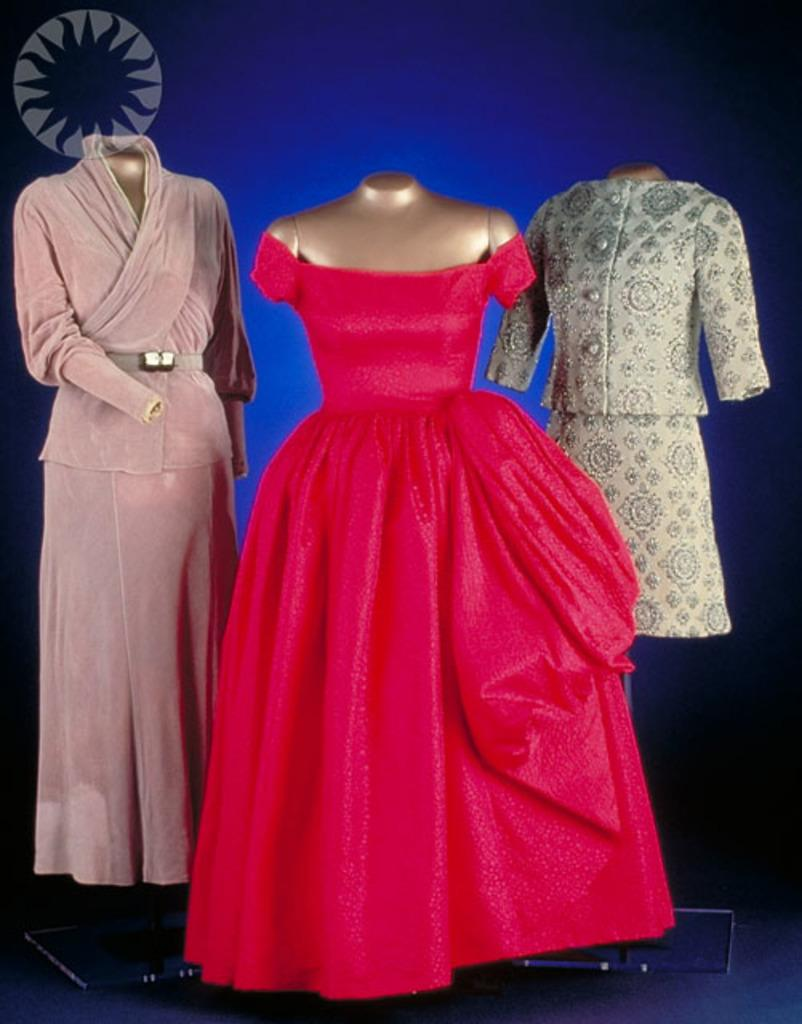What type of objects are present in the image? There are three headless mannequins in the image. What are the mannequins wearing? Each mannequin is wearing a different dress. What color is the background of the image? The background of the image is blue. How many brushes can be seen in the image? There are no brushes present in the image. What type of animal is standing next to the mannequins in the image? There are no animals, including sheep, present in the image. 